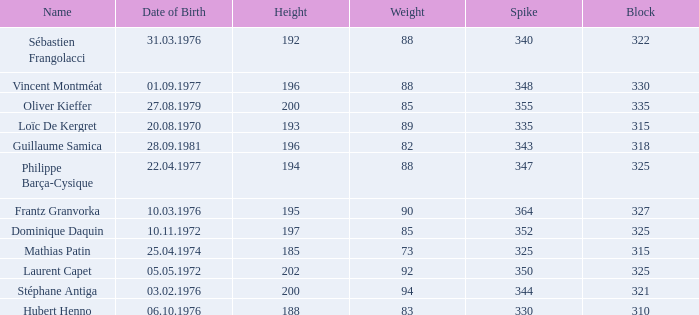How many spikes have 28.09.1981 as the date of birth, with a block greater than 318? None. 